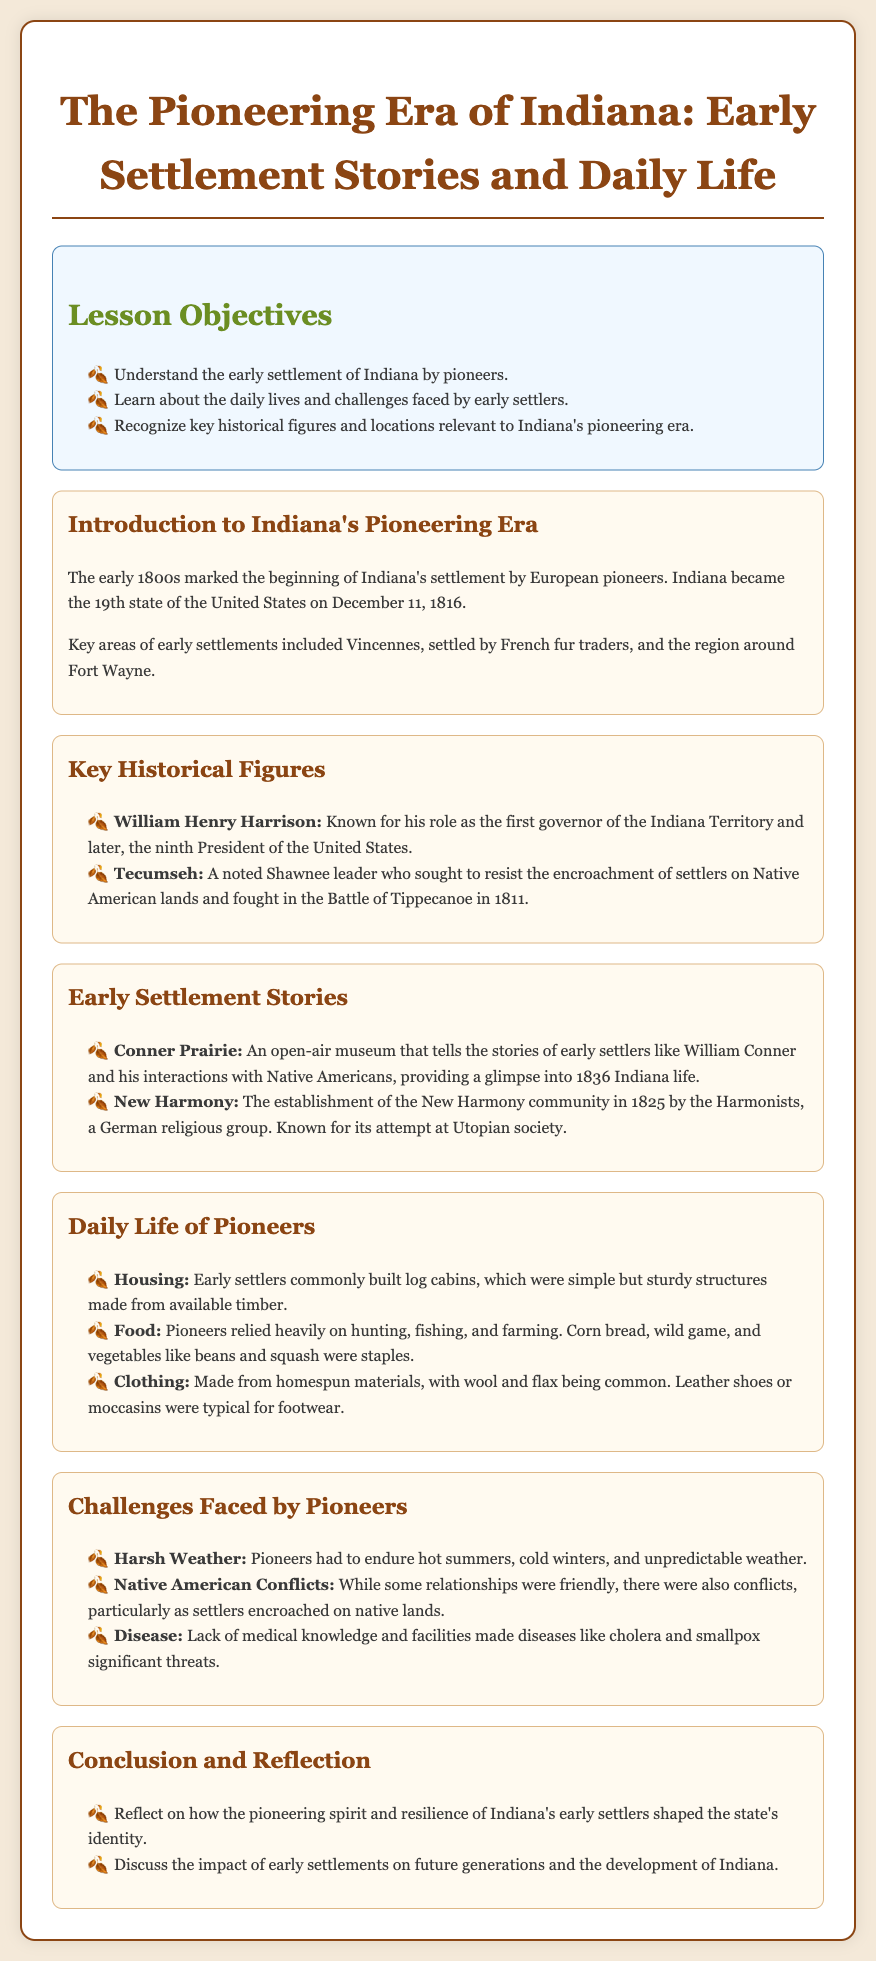What year did Indiana become a state? The document states that Indiana became the 19th state on December 11, 1816.
Answer: 1816 Who was the first governor of the Indiana Territory? The document identifies William Henry Harrison as the first governor of the Indiana Territory.
Answer: William Henry Harrison What food staple did pioneers rely on? The document mentions corn bread, wild game, and vegetables like beans and squash as staples for pioneers.
Answer: Corn bread What challenges did pioneers face regarding the weather? The document highlights that pioneers had to endure hot summers, cold winters, and unpredictable weather.
Answer: Harsh Weather What was the establishment year of New Harmony? According to the document, the New Harmony community was established in 1825.
Answer: 1825 Which settlement is known for its open-air museum? The document refers to Conner Prairie as the settlement known for its open-air museum.
Answer: Conner Prairie What were the common materials for pioneer clothing? The document states that pioneers made clothing from homespun materials, with wool and flax being common.
Answer: Wool and flax What impact did early settlements have on future generations? The document prompts reflection on the impact of early settlements on future generations and the development of Indiana.
Answer: Development of Indiana 